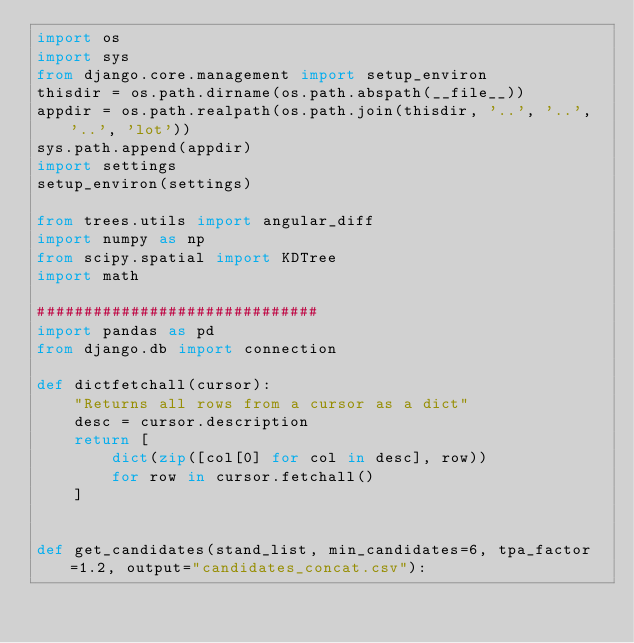<code> <loc_0><loc_0><loc_500><loc_500><_Python_>import os
import sys
from django.core.management import setup_environ
thisdir = os.path.dirname(os.path.abspath(__file__))
appdir = os.path.realpath(os.path.join(thisdir, '..', '..', '..', 'lot'))
sys.path.append(appdir)
import settings
setup_environ(settings)

from trees.utils import angular_diff
import numpy as np
from scipy.spatial import KDTree
import math

##############################
import pandas as pd
from django.db import connection

def dictfetchall(cursor):
    "Returns all rows from a cursor as a dict"
    desc = cursor.description
    return [
        dict(zip([col[0] for col in desc], row))
        for row in cursor.fetchall()
    ]


def get_candidates(stand_list, min_candidates=6, tpa_factor=1.2, output="candidates_concat.csv"):</code> 